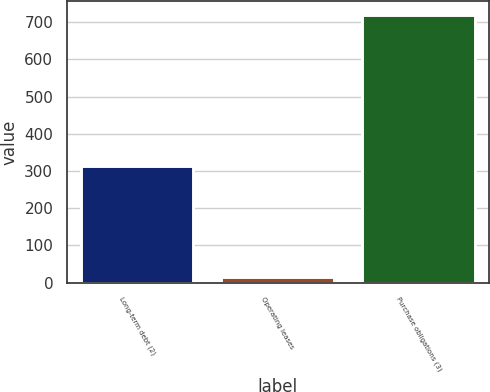Convert chart to OTSL. <chart><loc_0><loc_0><loc_500><loc_500><bar_chart><fcel>Long-term debt (2)<fcel>Operating leases<fcel>Purchase obligations (3)<nl><fcel>314<fcel>14<fcel>720<nl></chart> 